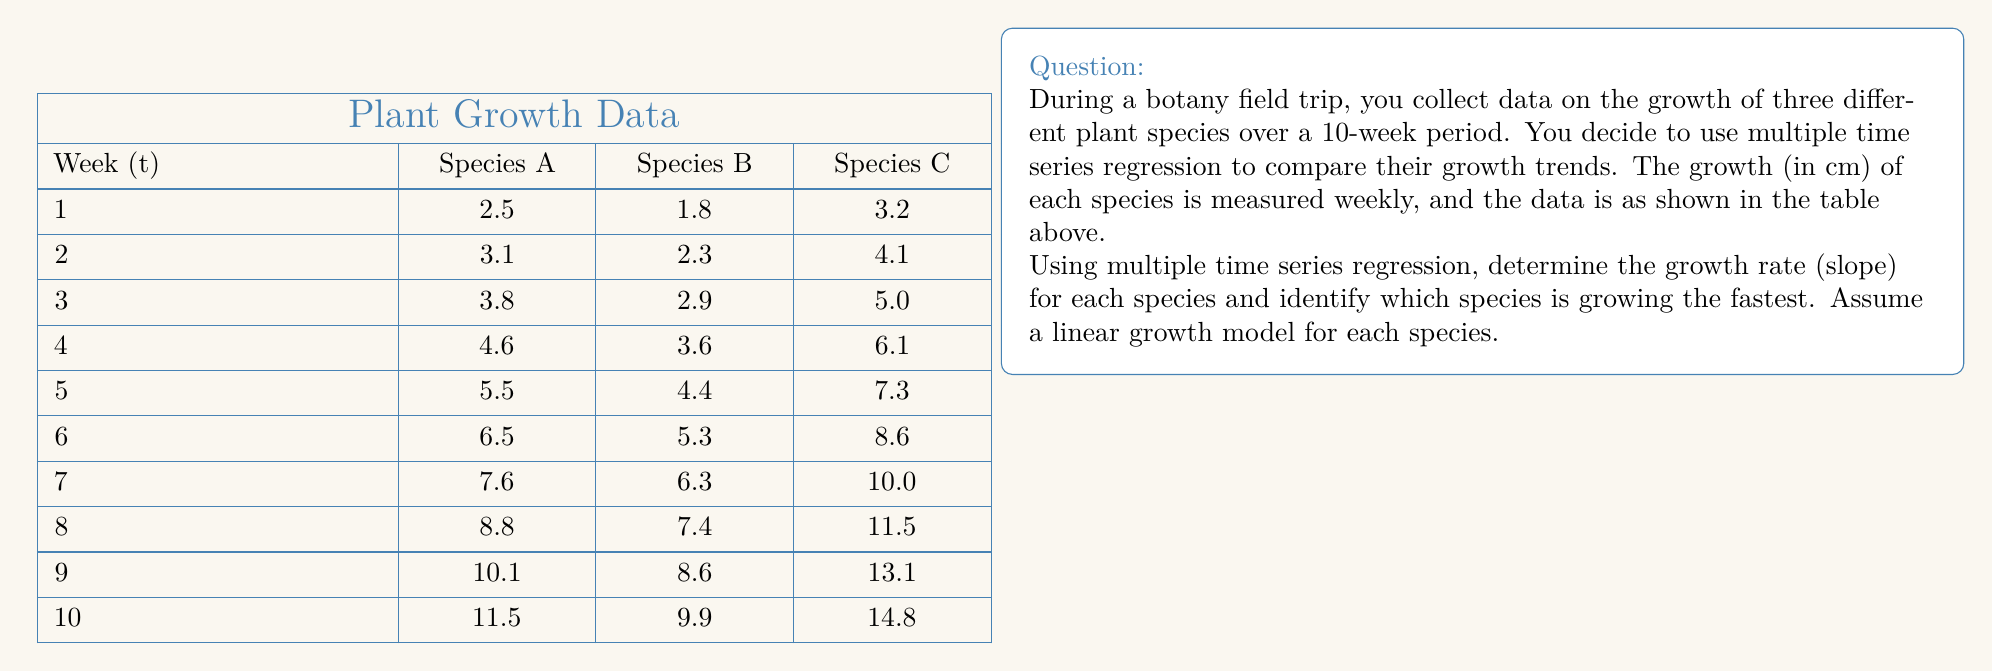Solve this math problem. To solve this problem, we'll use multiple time series regression with the following steps:

1) First, we need to set up our regression model. For each species, we'll use a linear model of the form:

   $$Y_i = \beta_0 + \beta_1t + \epsilon_i$$

   Where $Y_i$ is the growth, $\beta_0$ is the y-intercept, $\beta_1$ is the slope (growth rate), $t$ is the time (week), and $\epsilon_i$ is the error term.

2) We'll use the least squares method to estimate $\beta_0$ and $\beta_1$ for each species. The formulas for these estimates are:

   $$\beta_1 = \frac{n\sum{ty} - \sum{t}\sum{y}}{n\sum{t^2} - (\sum{t})^2}$$

   $$\beta_0 = \bar{y} - \beta_1\bar{t}$$

   Where $n$ is the number of observations, $\bar{y}$ is the mean of $y$, and $\bar{t}$ is the mean of $t$.

3) Let's calculate these values for each species:

   For Species A:
   $$\beta_1 = \frac{10(385.5) - 55(64)}{10(385) - 55^2} = 1.0$$
   $$\beta_0 = 6.4 - 1.0(5.5) = 0.9$$

   For Species B:
   $$\beta_1 = \frac{10(280.5) - 55(52.5)}{10(385) - 55^2} = 0.9$$
   $$\beta_0 = 5.25 - 0.9(5.5) = 0.3$$

   For Species C:
   $$\beta_1 = \frac{10(501) - 55(83.7)}{10(385) - 55^2} = 1.3$$
   $$\beta_0 = 8.37 - 1.3(5.5) = 1.22$$

4) The regression equations for each species are:

   Species A: $Y = 0.9 + 1.0t$
   Species B: $Y = 0.3 + 0.9t$
   Species C: $Y = 1.22 + 1.3t$

5) The slope ($\beta_1$) represents the growth rate for each species. Species C has the highest slope at 1.3 cm/week, indicating it's growing the fastest.
Answer: The growth rates (slopes) for each species are:
Species A: 1.0 cm/week
Species B: 0.9 cm/week
Species C: 1.3 cm/week

Species C is growing the fastest with a growth rate of 1.3 cm/week. 